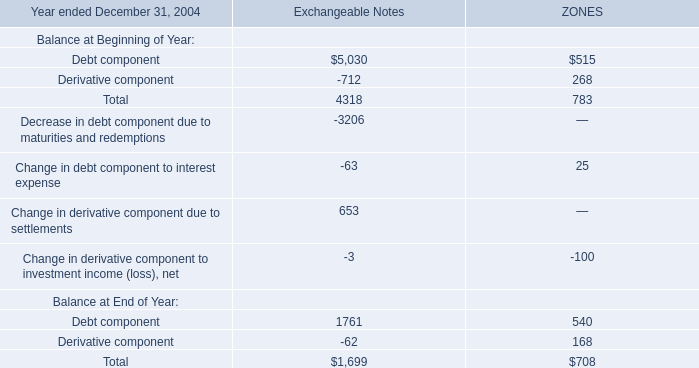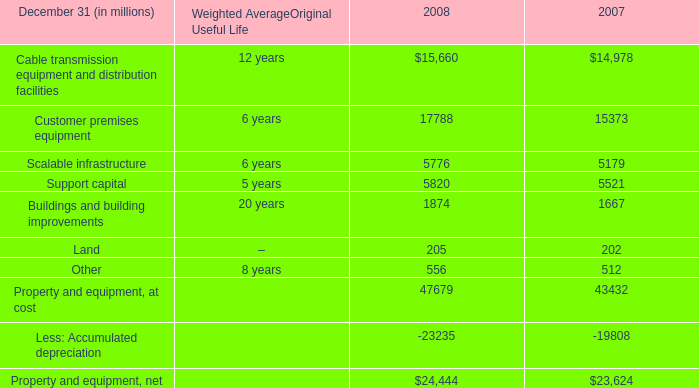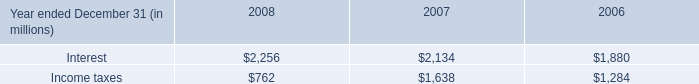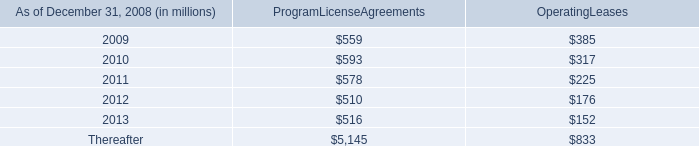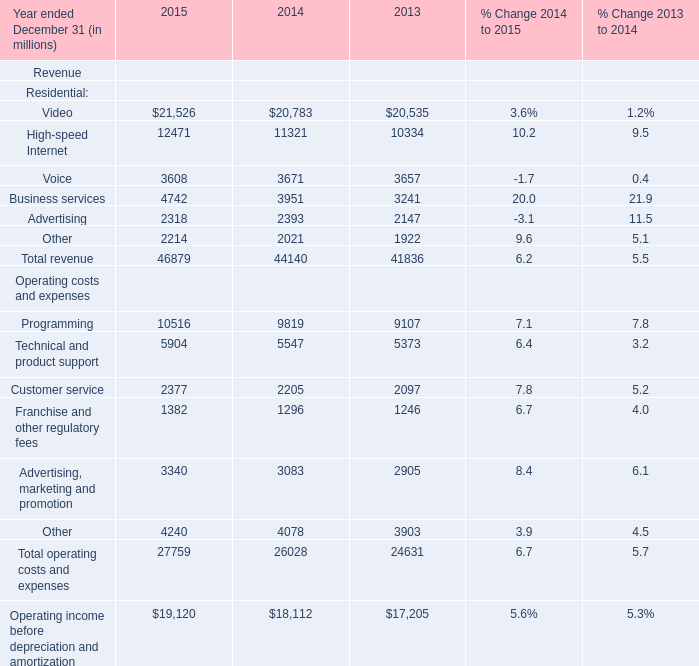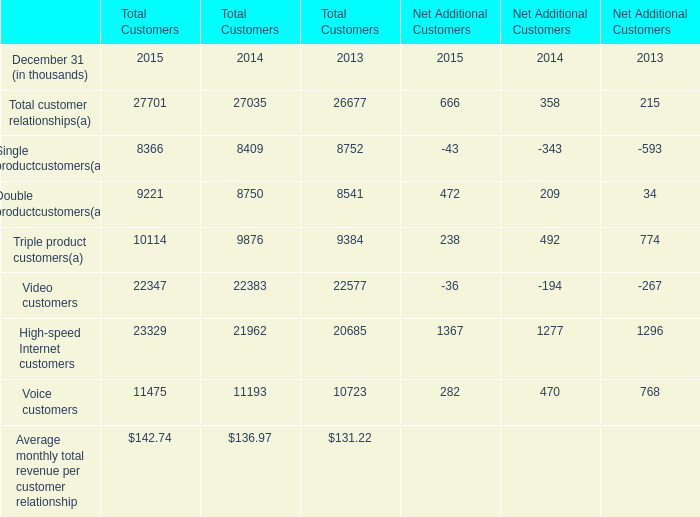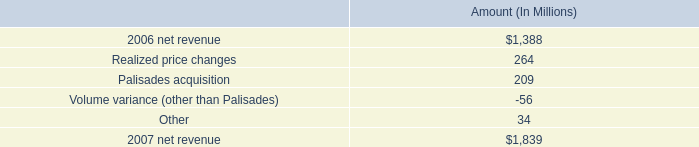What's the average of Net Additional Customers in 2015? (in thousand) 
Computations: (((((((666 - 43) + 472) + 238) - 36) + 1367) + 282) / 8)
Answer: 368.25. 